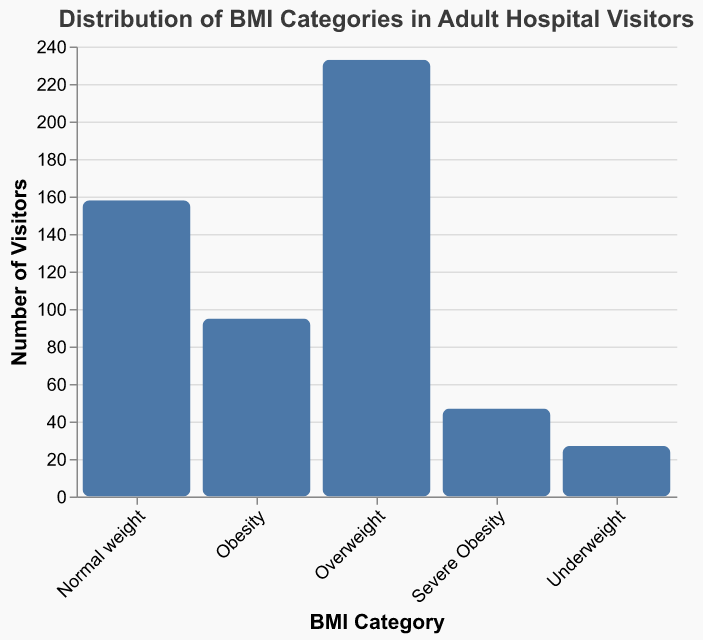How many BMI categories are represented in the figure? The figure shows bars for each BMI category, which can be counted. The categories are: Underweight, Normal weight, Overweight, Obesity, and Severe Obesity.
Answer: 5 Which BMI category has the highest frequency? The figure displays the height of the bars corresponding to each BMI category. The bar for Overweight is the highest, indicating it has the highest frequency.
Answer: Overweight What is the total frequency of hospital visitors across all BMI categories? To determine the total frequency, sum the frequencies of each category: 27 + 158 + 233 + 95 + 47.
Answer: 560 How many more visitors are in the 'Overweight' category compared to 'Normal weight'? Subtract the frequency of the 'Normal weight' category from the 'Overweight' category: 233 - 158.
Answer: 75 What is the ratio of visitors in the 'Obesity' category to the 'Underweight' category? Calculate the ratio by dividing the frequency of 'Obesity' by the frequency of 'Underweight': 95 / 27.
Answer: 3.52 Are there more visitors in the 'Severe Obesity' category or the 'Underweight' category? Compare the heights of the bars for 'Severe Obesity' and 'Underweight'. The 'Underweight' category has 27 visitors, while the 'Severe Obesity' category has 47 visitors.
Answer: Severe Obesity What percentage of total visitors fall into the 'Normal weight' category? First, calculate the total number of visitors (560), then divide the number of 'Normal weight' visitors by total visitors and multiply by 100: (158 / 560) * 100.
Answer: 28.21% What is the combined frequency of 'Overweight' and 'Obesity' visitors? Add the frequencies of the 'Overweight' and 'Obesity' categories: 233 + 95.
Answer: 328 Which categories have a frequency less than 100? Identify the bars representing categories with frequencies below 100. These are 'Underweight' (27), 'Severe Obesity' (47), and 'Obesity' (95).
Answer: Underweight, Severe Obesity, Obesity What is the average frequency of visitors per BMI category? Calculate the total frequency (560) and then divide by the number of categories (5): 560 / 5.
Answer: 112 